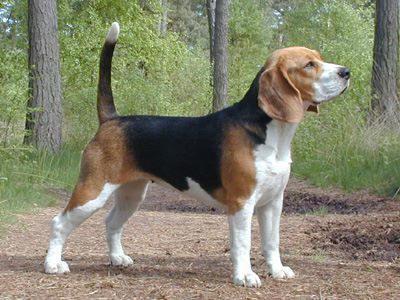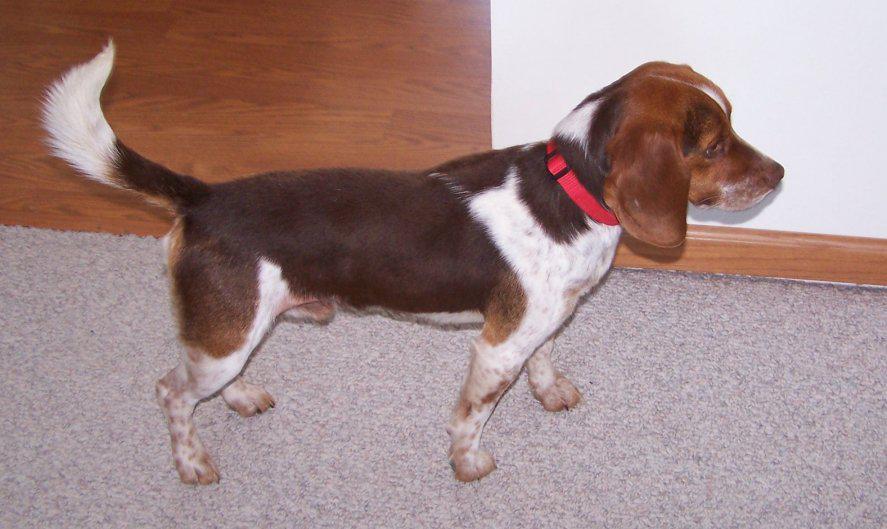The first image is the image on the left, the second image is the image on the right. For the images shown, is this caption "There is at least two dogs in the left image." true? Answer yes or no. No. The first image is the image on the left, the second image is the image on the right. For the images shown, is this caption "Each image contains one beagle standing on all fours with its tail up, and the beagle on the right wears a red collar." true? Answer yes or no. Yes. 